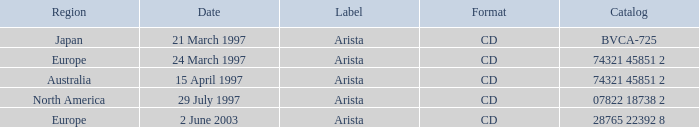What's the Date with the Region of Europe and has a Catalog of 28765 22392 8? 2 June 2003. 